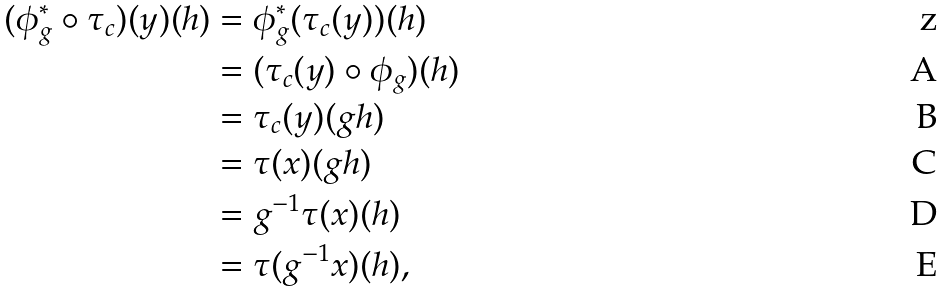<formula> <loc_0><loc_0><loc_500><loc_500>( \phi _ { g } ^ { * } \circ \tau _ { c } ) ( y ) ( h ) & = \phi _ { g } ^ { * } ( \tau _ { c } ( y ) ) ( h ) \\ & = ( \tau _ { c } ( y ) \circ \phi _ { g } ) ( h ) \\ & = \tau _ { c } ( y ) ( g h ) \\ & = \tau ( x ) ( g h ) \\ & = g ^ { - 1 } \tau ( x ) ( h ) \\ & = \tau ( g ^ { - 1 } x ) ( h ) ,</formula> 